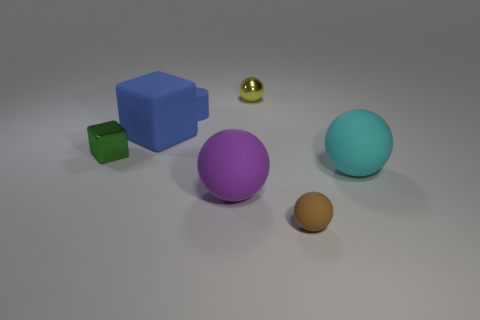Subtract all brown spheres. How many spheres are left? 3 Subtract all purple balls. How many balls are left? 3 Subtract 1 cubes. How many cubes are left? 1 Add 3 cyan matte cylinders. How many objects exist? 10 Subtract all cylinders. How many objects are left? 6 Subtract all cyan balls. Subtract all small brown matte balls. How many objects are left? 5 Add 4 tiny things. How many tiny things are left? 8 Add 3 small blocks. How many small blocks exist? 4 Subtract 0 red balls. How many objects are left? 7 Subtract all yellow cylinders. Subtract all blue cubes. How many cylinders are left? 1 